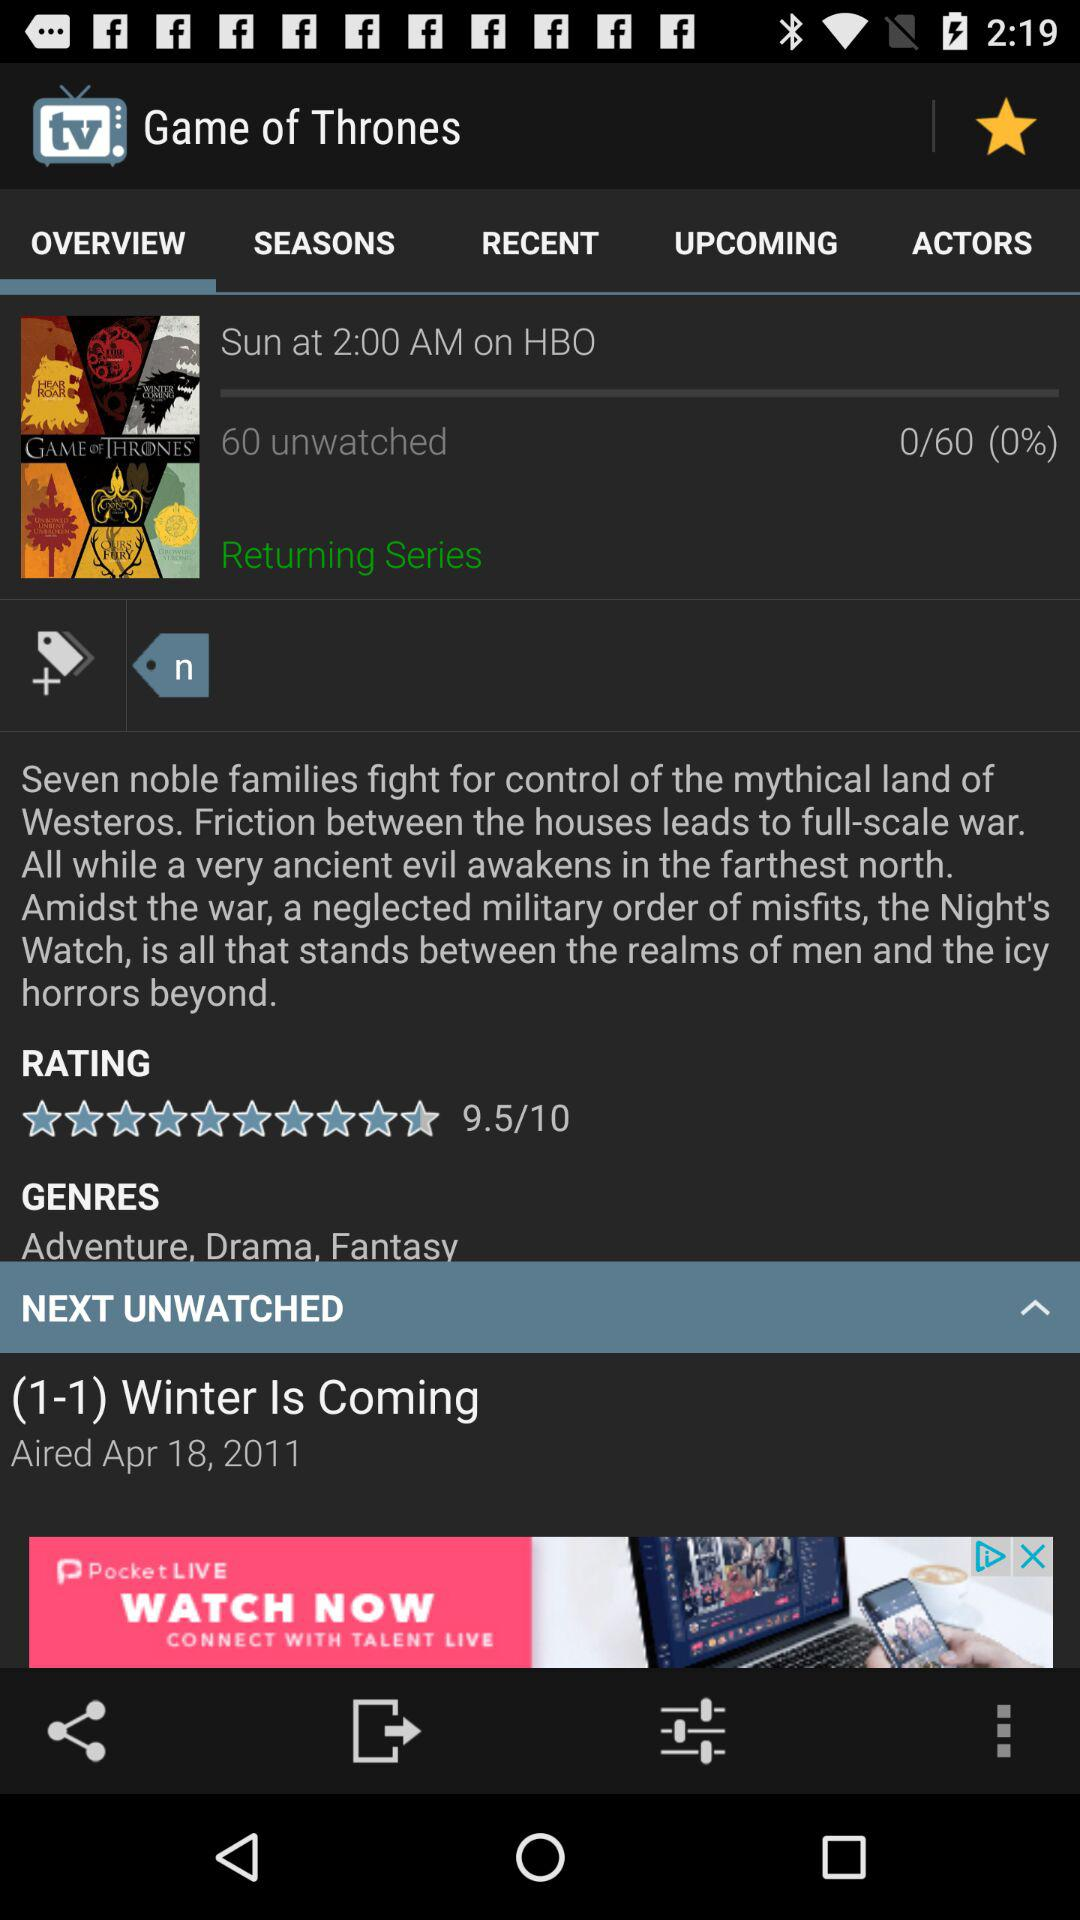How many episodes are unwatched?
Answer the question using a single word or phrase. 60 